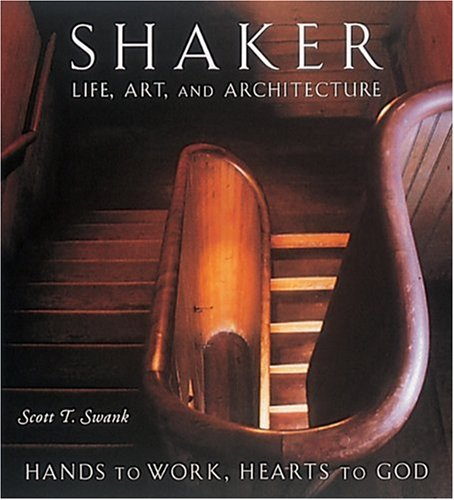Can you provide more details about the Shaker community's influence on American culture? The Shakers, officially known as the United Society of Believers in Christ's Second Appearing, had a significant influence on American culture, particularly in furniture design and craftsmanship. Their principles of simplicity and functionality have inspired numerous modern design philosophies. 